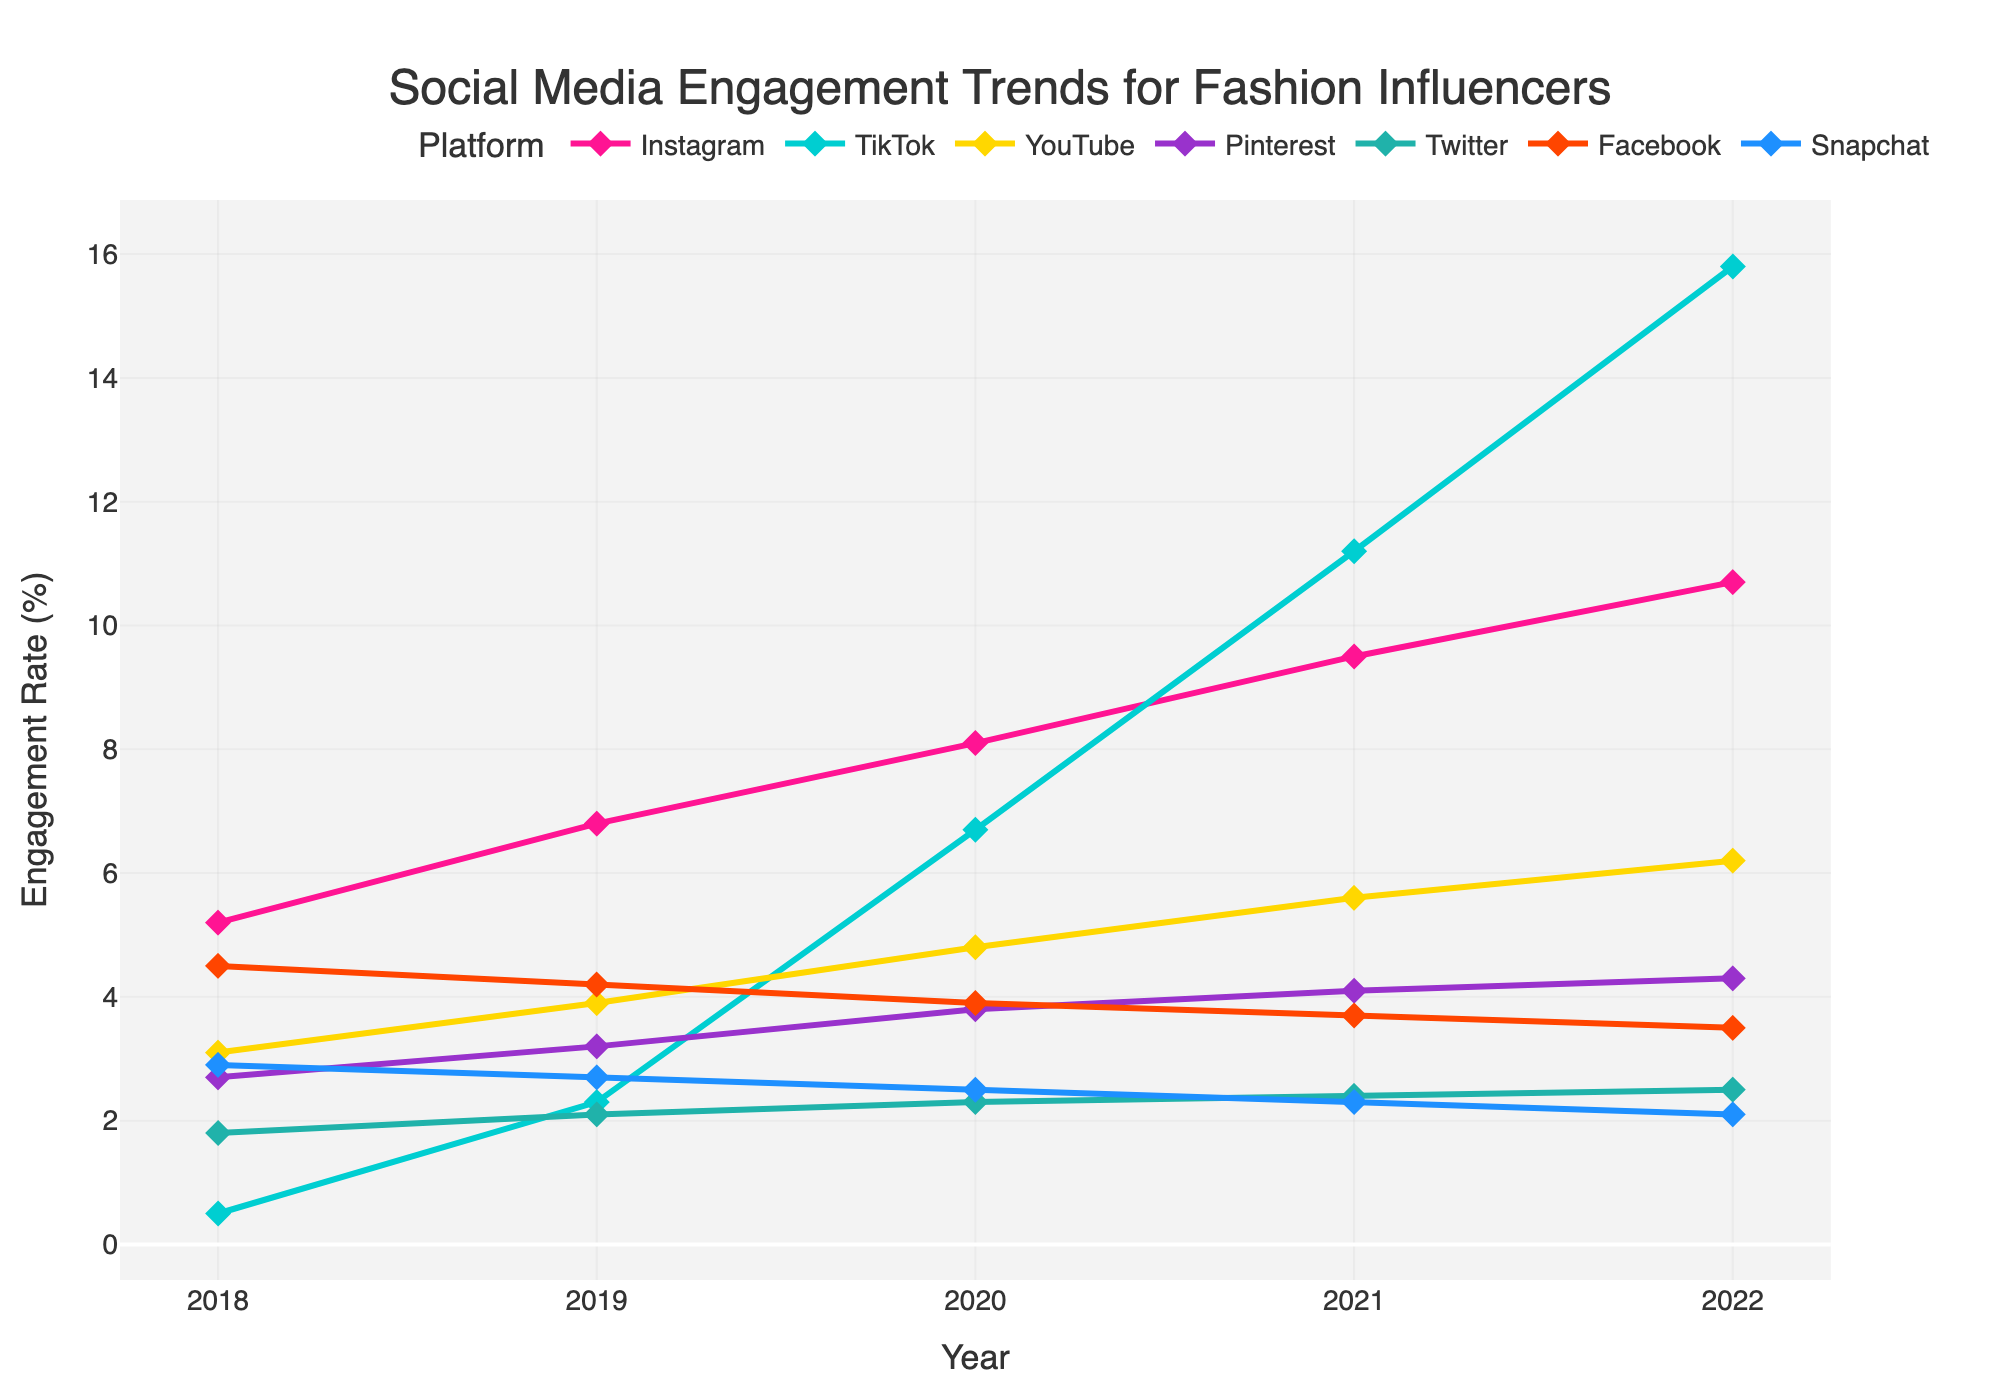What platform demonstrated the highest engagement rate in 2022? Look at the endpoints of each line corresponding to 2022. Identify which line reaches the highest point on the y-axis. TikTok has the highest engagement rate in 2022.
Answer: TikTok Which platform had the lowest engagement rate growth from 2018 to 2022? Subtract the engagement rate of each platform in 2018 from its corresponding value in 2022 and identify the platform with the smallest difference. Twitter had the lowest engagement rate growth from 2018 to 2022 (difference of 0.7).
Answer: Twitter Between 2020 and 2021, which platform experienced the most significant increase in engagement rate? Observe the slope of the lines between 2020 and 2021 for each platform and see which line has the steepest upward section. TikTok had the most significant increase in engagement rate between 2020 and 2021.
Answer: TikTok What is the average engagement rate on Pinterest from 2018 to 2022? Sum the engagement rates of Pinterest from 2018 to 2022 and then divide by the number of years (5). \((2.7 + 3.2 + 3.8 + 4.1 + 4.3) / 5 = 3.62\)
Answer: 3.62 Which platform saw a continuous decline in engagement from 2018 to 2022? Examine the trend of each line from 2018 to 2022 and find the line that continuously goes downward. Facebook and Snapchat saw a continuous decline in engagement.
Answer: Facebook and Snapchat How much higher was Instagram’s engagement than Twitter’s in 2022? Find the difference between Instagram's and Twitter's engagement rate in 2022. Instagram’s engagement in 2022 is 10.7, and Twitter’s is 2.5, so the difference is \(10.7 - 2.5 = 8.2\)
Answer: 8.2 Which two platforms were closest in engagement rates in 2020? Compare the engagement rates of all platforms in 2020 and find the smallest difference. Twitter and Snapchat had engagement rates of 2.3 and 2.5, respectively, which is the smallest difference (0.2).
Answer: Twitter and Snapchat By what percentage did TikTok's engagement rate increase from 2019 to 2022? Calculate the percentage increase by taking the difference between engagement rates in 2022 and 2019, and then divide by the 2019 rate. \(\frac{15.8 - 2.3}{2.3} \times 100 = 586.96\%\)
Answer: 586.96 What year did Instagram overtake YouTube in engagement rate? Identify the year where Instagram's engagement rate first becomes higher than YouTube's. In 2019, Instagram's engagement rate (6.8) overtakes YouTube's (3.9).
Answer: 2019 